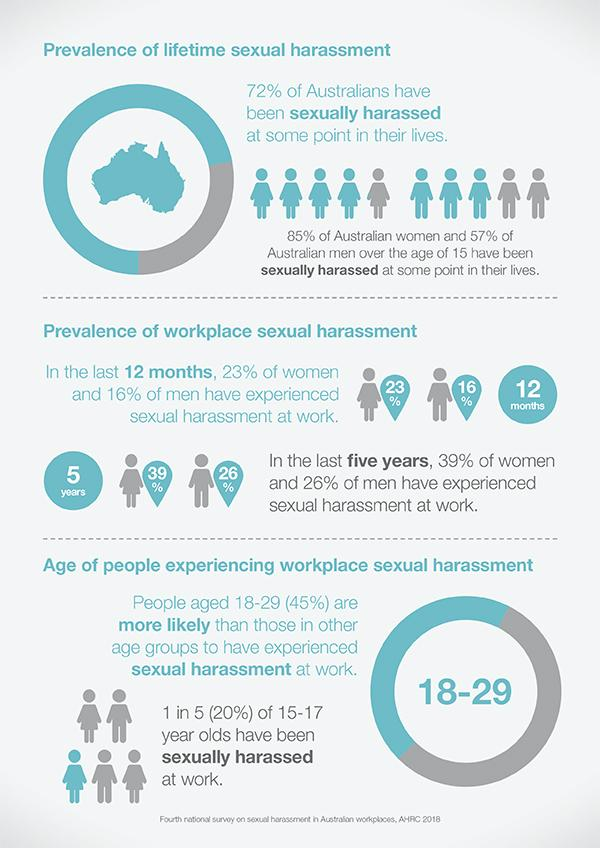Highlight a few significant elements in this photo. Women are the group that has faced sexual harassment the most in Australia. 